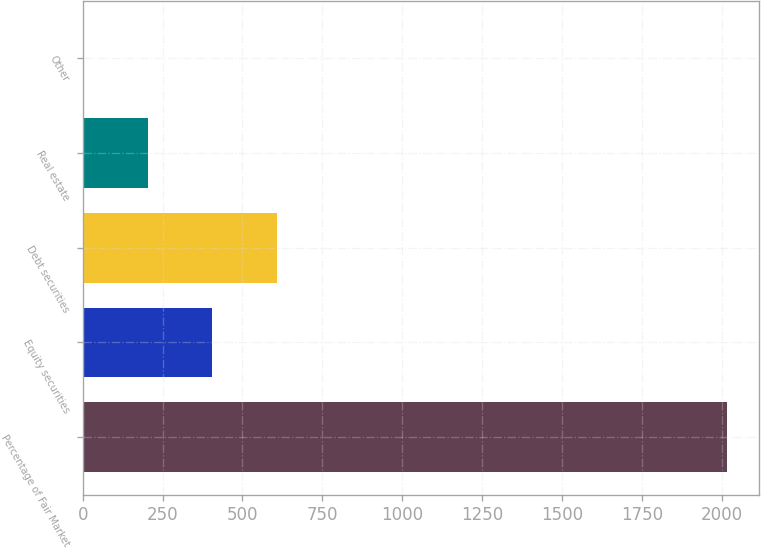<chart> <loc_0><loc_0><loc_500><loc_500><bar_chart><fcel>Percentage of Fair Market<fcel>Equity securities<fcel>Debt securities<fcel>Real estate<fcel>Other<nl><fcel>2015<fcel>405.72<fcel>606.88<fcel>204.56<fcel>3.4<nl></chart> 